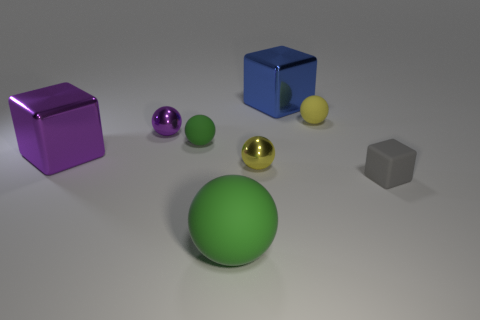Subtract all purple spheres. How many spheres are left? 4 Subtract all red balls. Subtract all blue cylinders. How many balls are left? 5 Add 2 big purple cubes. How many objects exist? 10 Subtract all spheres. How many objects are left? 3 Add 2 large brown metallic objects. How many large brown metallic objects exist? 2 Subtract 0 red blocks. How many objects are left? 8 Subtract all small balls. Subtract all yellow rubber spheres. How many objects are left? 3 Add 5 small matte blocks. How many small matte blocks are left? 6 